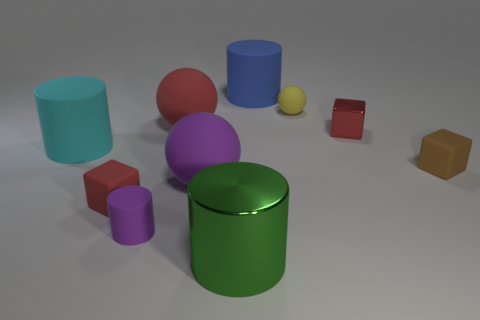What number of other things are there of the same material as the purple ball
Your response must be concise. 7. What number of large objects are either gray metallic things or green metal things?
Your answer should be very brief. 1. There is a large rubber ball in front of the matte cube on the right side of the green object; are there any blue matte objects to the left of it?
Your response must be concise. No. Are there any purple rubber spheres that have the same size as the yellow sphere?
Your answer should be compact. No. There is a cylinder that is the same size as the brown matte cube; what is it made of?
Give a very brief answer. Rubber. Is the size of the cyan rubber cylinder the same as the red matte thing behind the tiny brown object?
Keep it short and to the point. Yes. How many rubber objects are either red cubes or large brown cylinders?
Give a very brief answer. 1. What number of gray things are the same shape as the large cyan thing?
Give a very brief answer. 0. There is a big ball that is the same color as the tiny shiny cube; what is it made of?
Keep it short and to the point. Rubber. Is the size of the purple object that is to the left of the purple rubber ball the same as the red rubber object that is in front of the small brown rubber object?
Give a very brief answer. Yes. 